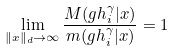<formula> <loc_0><loc_0><loc_500><loc_500>\lim _ { \| x \| _ { d } \to \infty } \frac { M ( g h _ { i } ^ { \gamma } | x ) } { m ( g h _ { i } ^ { \gamma } | x ) } = 1</formula> 